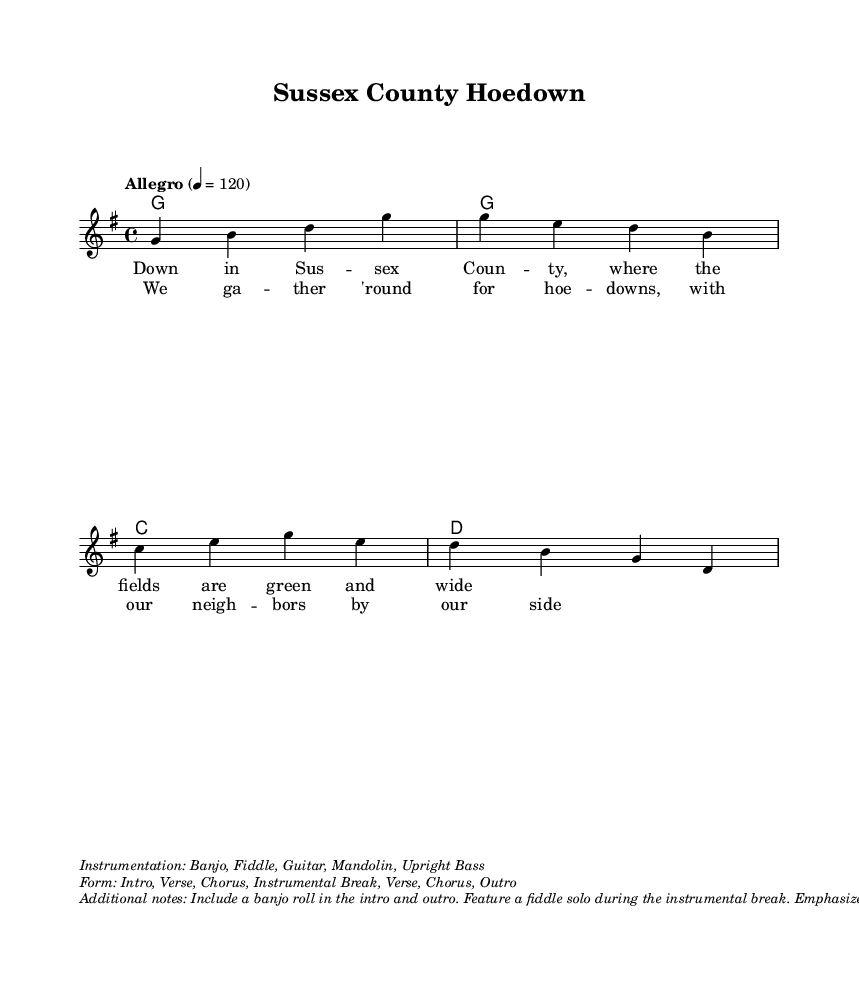What is the key signature of this music? The key signature is G major, which has one sharp (F#). The G major key signature can be identified at the beginning of the staff.
Answer: G major What is the time signature of this piece? The time signature is 4/4, which indicates that there are four beats in each measure and the quarter note gets one beat. This can be observed at the beginning of the score.
Answer: 4/4 What is the tempo marking for this performance? The tempo marking is "Allegro," indicating a fast and lively pace. It is marked above the staff, along with a metronome indication of quarter note = 120.
Answer: Allegro How many verses does this song contain? The song contains two verses as indicated by the two different lyric sections labeled as verseOne and verseTwo. Each section contains distinct lyrics.
Answer: 2 What instruments are specified in the instrumentation? The specified instruments include Banjo, Fiddle, Guitar, Mandolin, and Upright Bass, which are listed in the additional notes section underneath the main score.
Answer: Banjo, Fiddle, Guitar, Mandolin, Upright Bass What is the form of this piece? The form includes Intro, Verse, Chorus, Instrumental Break, Verse, Chorus, and Outro, as detailed in the additional notes section. This describes the structural layout of the piece.
Answer: Intro, Verse, Chorus, Instrumental Break, Verse, Chorus, Outro What is emphasized in the chorus according to the additional notes? The additional notes state that tight vocal harmonies are to be emphasized during the chorus, indicating a focus on the blend and coherence of the singers' voices at that part.
Answer: Tight vocal harmonies 